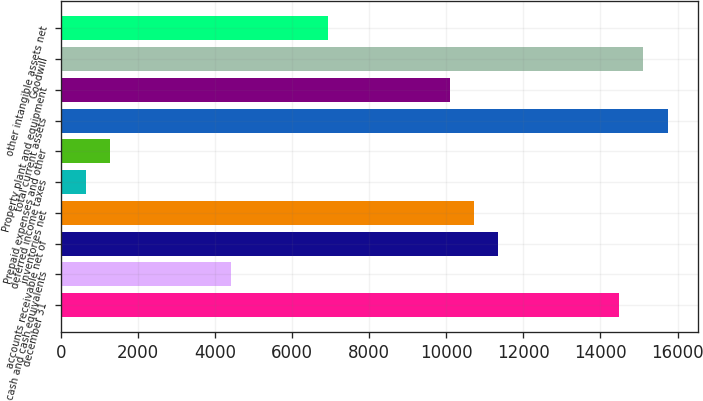Convert chart to OTSL. <chart><loc_0><loc_0><loc_500><loc_500><bar_chart><fcel>december 31<fcel>cash and cash equivalents<fcel>accounts receivable net of<fcel>inventories net<fcel>deferred income taxes<fcel>Prepaid expenses and other<fcel>total current assets<fcel>Property plant and equipment<fcel>Goodwill<fcel>other intangible assets net<nl><fcel>14483.1<fcel>4424.52<fcel>11339.8<fcel>10711.1<fcel>652.56<fcel>1281.22<fcel>15740.4<fcel>10082.5<fcel>15111.7<fcel>6939.16<nl></chart> 